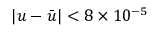<formula> <loc_0><loc_0><loc_500><loc_500>\left | u - { \bar { u } } \right | < 8 \times 1 0 ^ { - 5 }</formula> 